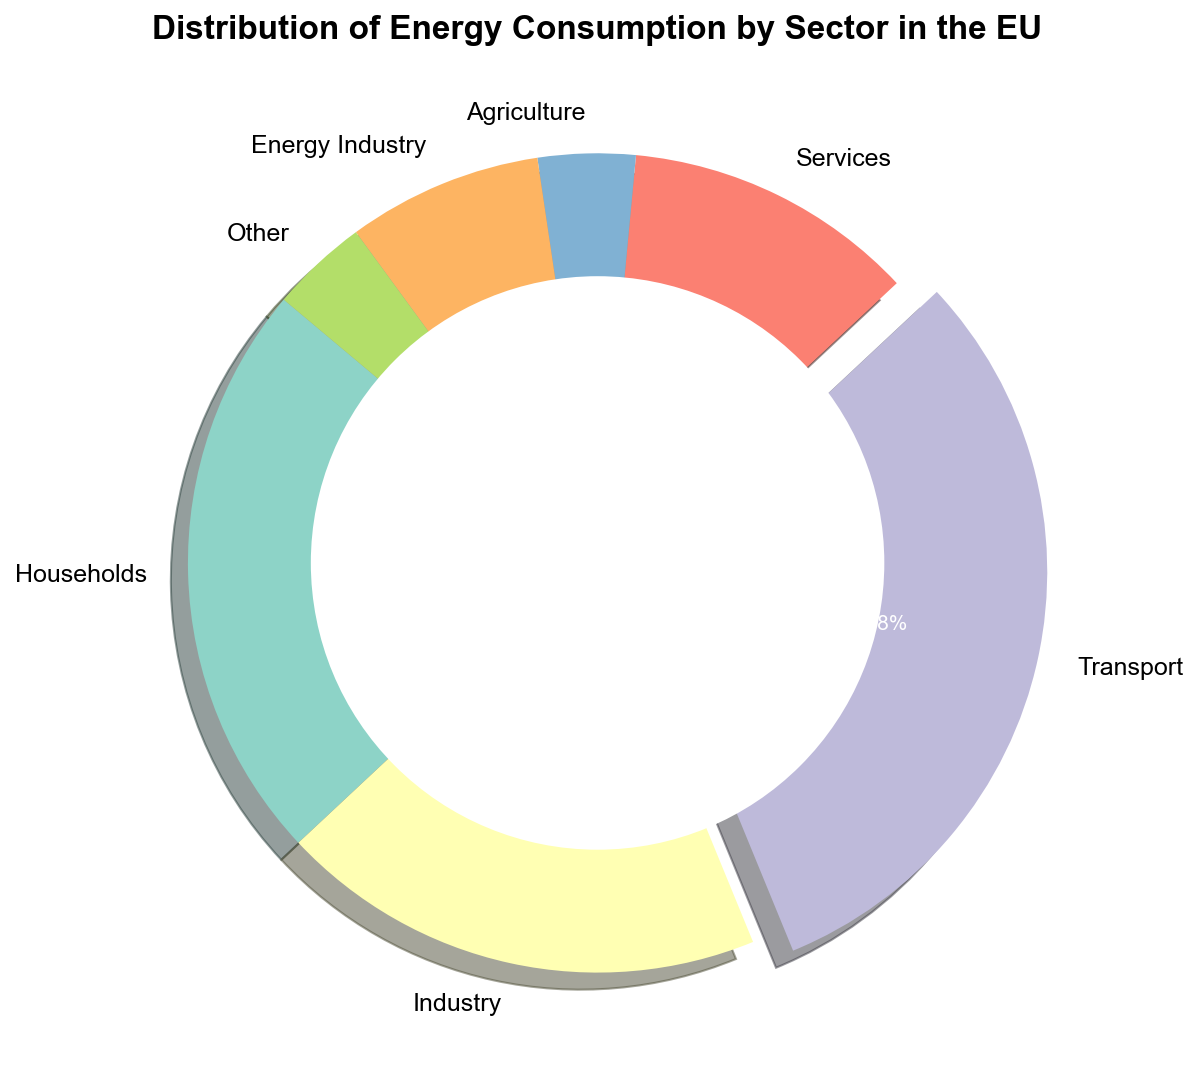what is the sector with the highest energy consumption? Look at the pie chart and identify the sector associated with the largest wedge. The sector with the largest wedge is Transport.
Answer: Transport What percentage of the total energy consumption is attributed to Industry and Services combined? First, find the individual percentages for Industry and Services. Industry is labeled as 250 TWh (25%) and Services as 150 TWh (15%). Add these percentages together (25% + 15%) to get the combined percentage.
Answer: 40% Which sector has the smallest contribution to the energy consumption? Look at the pie chart and identify the sector associated with the smallest wedge. The smallest wedge corresponds to Agriculture and Other, both with 50 TWh.
Answer: Agriculture and Other How much more energy does the Transport sector consume compared to the Agriculture sector? Find the energy consumption of the Transport sector (400 TWh) and the Agriculture sector (50 TWh). Subtract the agriculture consumption from the transport consumption (400 TWh - 50 TWh).
Answer: 350 TWh If you combine the energy consumption of Households and the Energy Industry, what fraction of the total energy consumption does this represent? First, add the energy consumptions of Households (300 TWh) and Energy Industry (100 TWh) to get 400 TWh. Then, calculate the total energy consumption (1300 TWh). The fraction is calculated as 400 TWh / 1300 TWh.
Answer: 4/13 Between Services and Agriculture, which sector has a larger share of energy consumption and by how much? Find the energy consumption for Services (150 TWh) and Agriculture (50 TWh). Services have a larger share. Subtract the Agriculture consumption from Services consumption (150 TWh - 50 TWh).
Answer: Services by 100 TWh What is the aggregate energy consumption for the sectors contributing less than 10% each to the total? Identify the sectors with less than 10% share: Agriculture (50 TWh), Energy Industry (100 TWh), and Other (50 TWh). Sum these values (50 TWh + 100 TWh + 50 TWh).
Answer: 200 TWh Is the energy consumption by the Household sector more than double that of the Services sector? Compare the energy consumption of Households (300 TWh) with twice the energy consumption of Services (2 × 150 TWh = 300 TWh). Since 300 TWh is equal to 300 TWh, it is not more but equal.
Answer: No What proportion of total energy consumption is used by sectors other than Transport and Households? Subtract the energy consumption of Transport (400 TWh) and Households (300 TWh) from the total (1300 TWh). Calculate the percentage of the remainder (600 TWh) out of the total (1300 TWh).
Answer: 46.2% Which sector is represented by the wedge that is exploded outwards in the pie chart, and why? Look at the pie chart and identify the wedge that is separated from the others. The exploded wedge corresponds to the Transport sector because it has the highest energy consumption.
Answer: Transport 